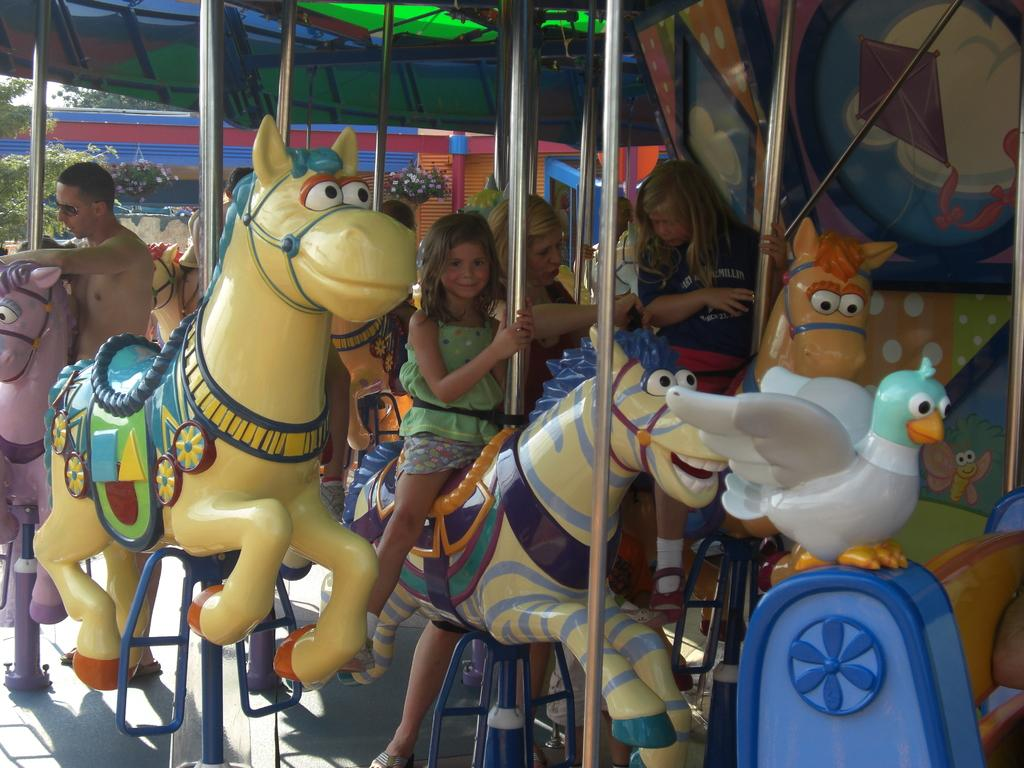Who is present in the image? There are children and people in the image. What are the children and people doing in the image? They are sitting on a horse ride. What can be seen in the background of the image? There are trees in the background of the image. Where is the sink located in the image? There is no sink present in the image. What type of corn can be seen growing near the horse ride? There is no corn present in the image. 